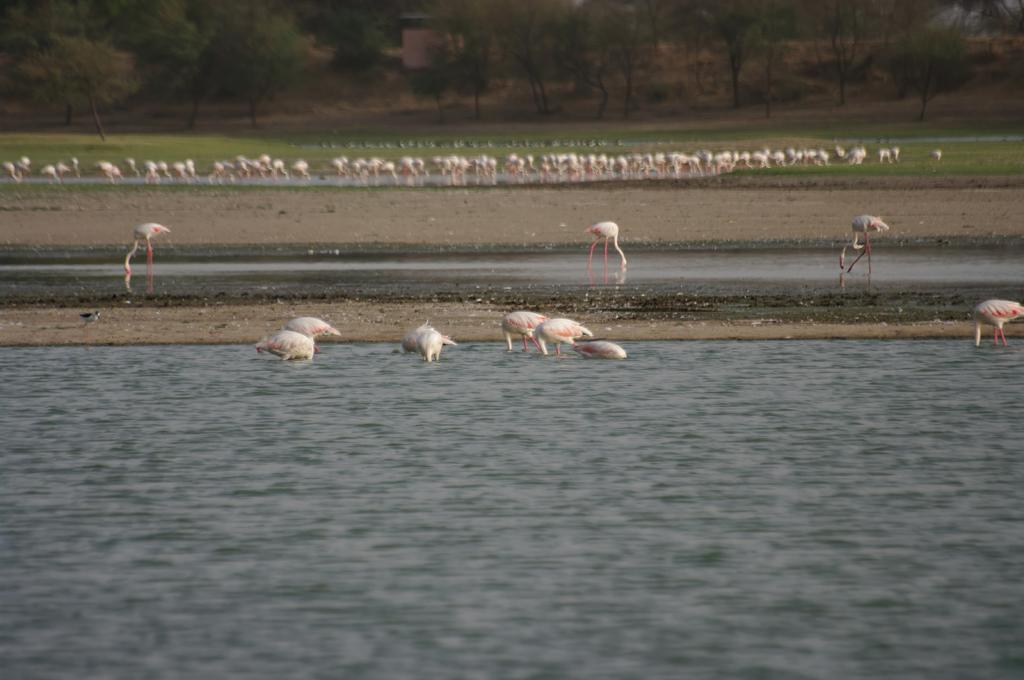What is located at the bottom of the image? There is a river at the bottom of the image. What can be seen in the center of the image? There are cranes in the center of the image. What is visible in the background of the image? There are cranes, water, grass, trees, and a building in the background of the image. How much milk is being poured into the river in the image? There is no milk being poured into the river in the image. What type of memory is being stored in the cranes in the image? There is no indication of memory storage in the cranes in the image. 